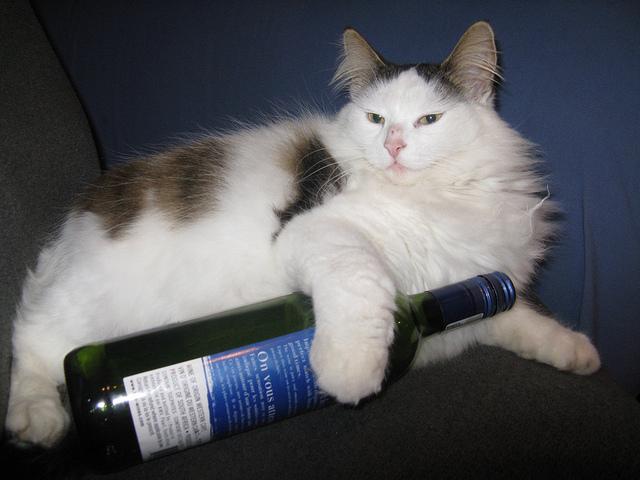What is the cat holding?
Short answer required. Bottle. What is the cat sitting on?
Quick response, please. Couch. Where was this photo taken?
Concise answer only. Home. 